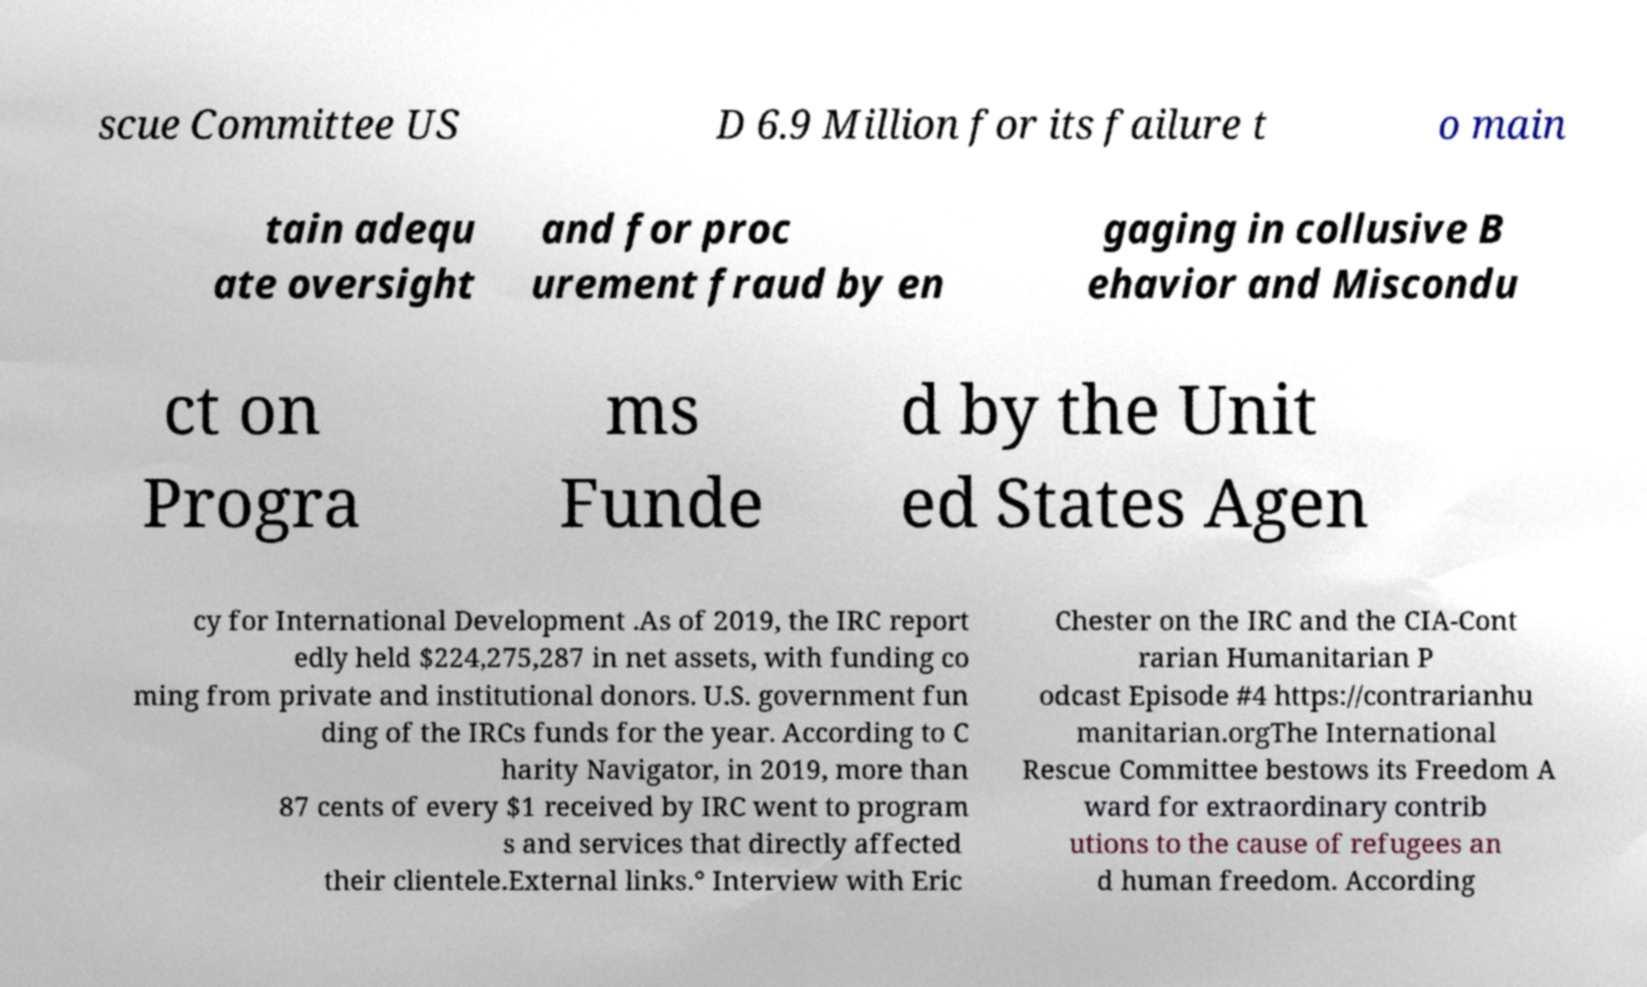There's text embedded in this image that I need extracted. Can you transcribe it verbatim? scue Committee US D 6.9 Million for its failure t o main tain adequ ate oversight and for proc urement fraud by en gaging in collusive B ehavior and Miscondu ct on Progra ms Funde d by the Unit ed States Agen cy for International Development .As of 2019, the IRC report edly held $224,275,287 in net assets, with funding co ming from private and institutional donors. U.S. government fun ding of the IRCs funds for the year. According to C harity Navigator, in 2019, more than 87 cents of every $1 received by IRC went to program s and services that directly affected their clientele.External links.° Interview with Eric Chester on the IRC and the CIA-Cont rarian Humanitarian P odcast Episode #4 https://contrarianhu manitarian.orgThe International Rescue Committee bestows its Freedom A ward for extraordinary contrib utions to the cause of refugees an d human freedom. According 